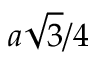<formula> <loc_0><loc_0><loc_500><loc_500>a \sqrt { 3 } / 4</formula> 